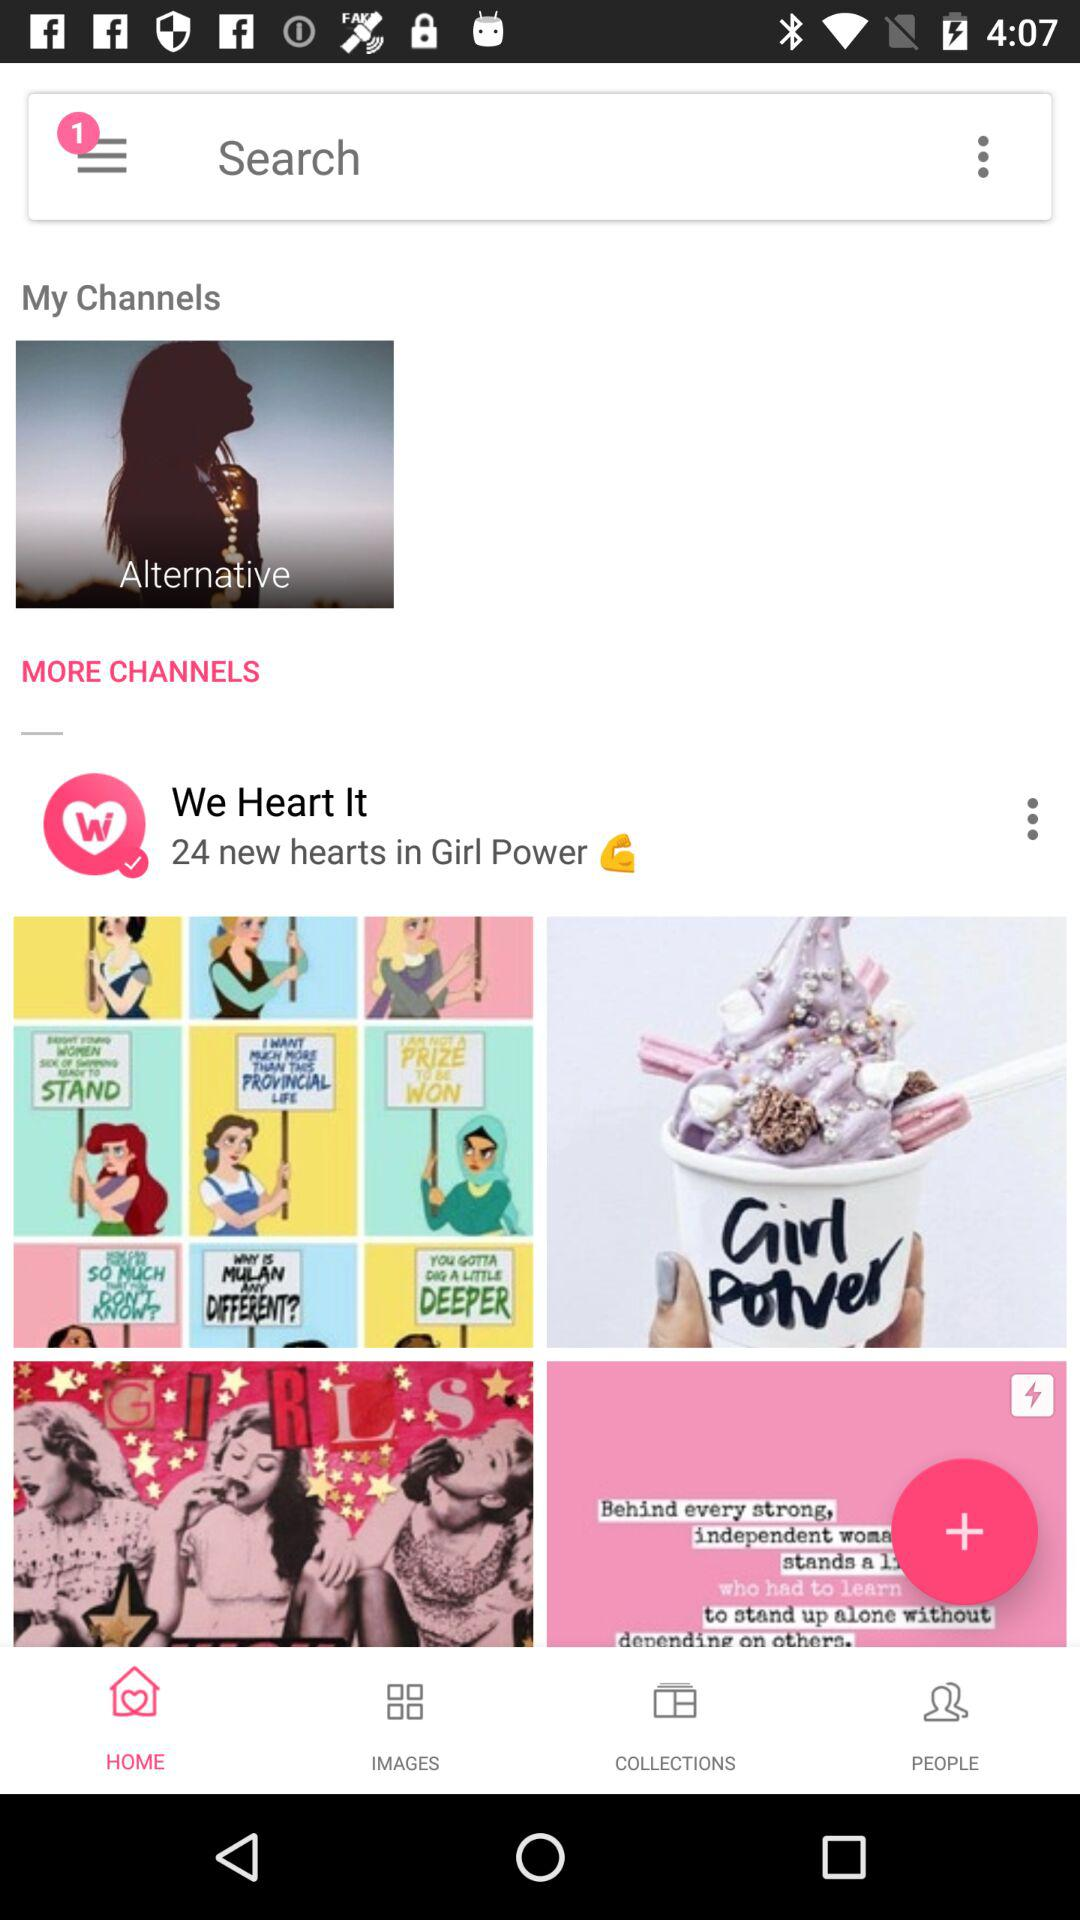How many images are in the collections?
When the provided information is insufficient, respond with <no answer>. <no answer> 